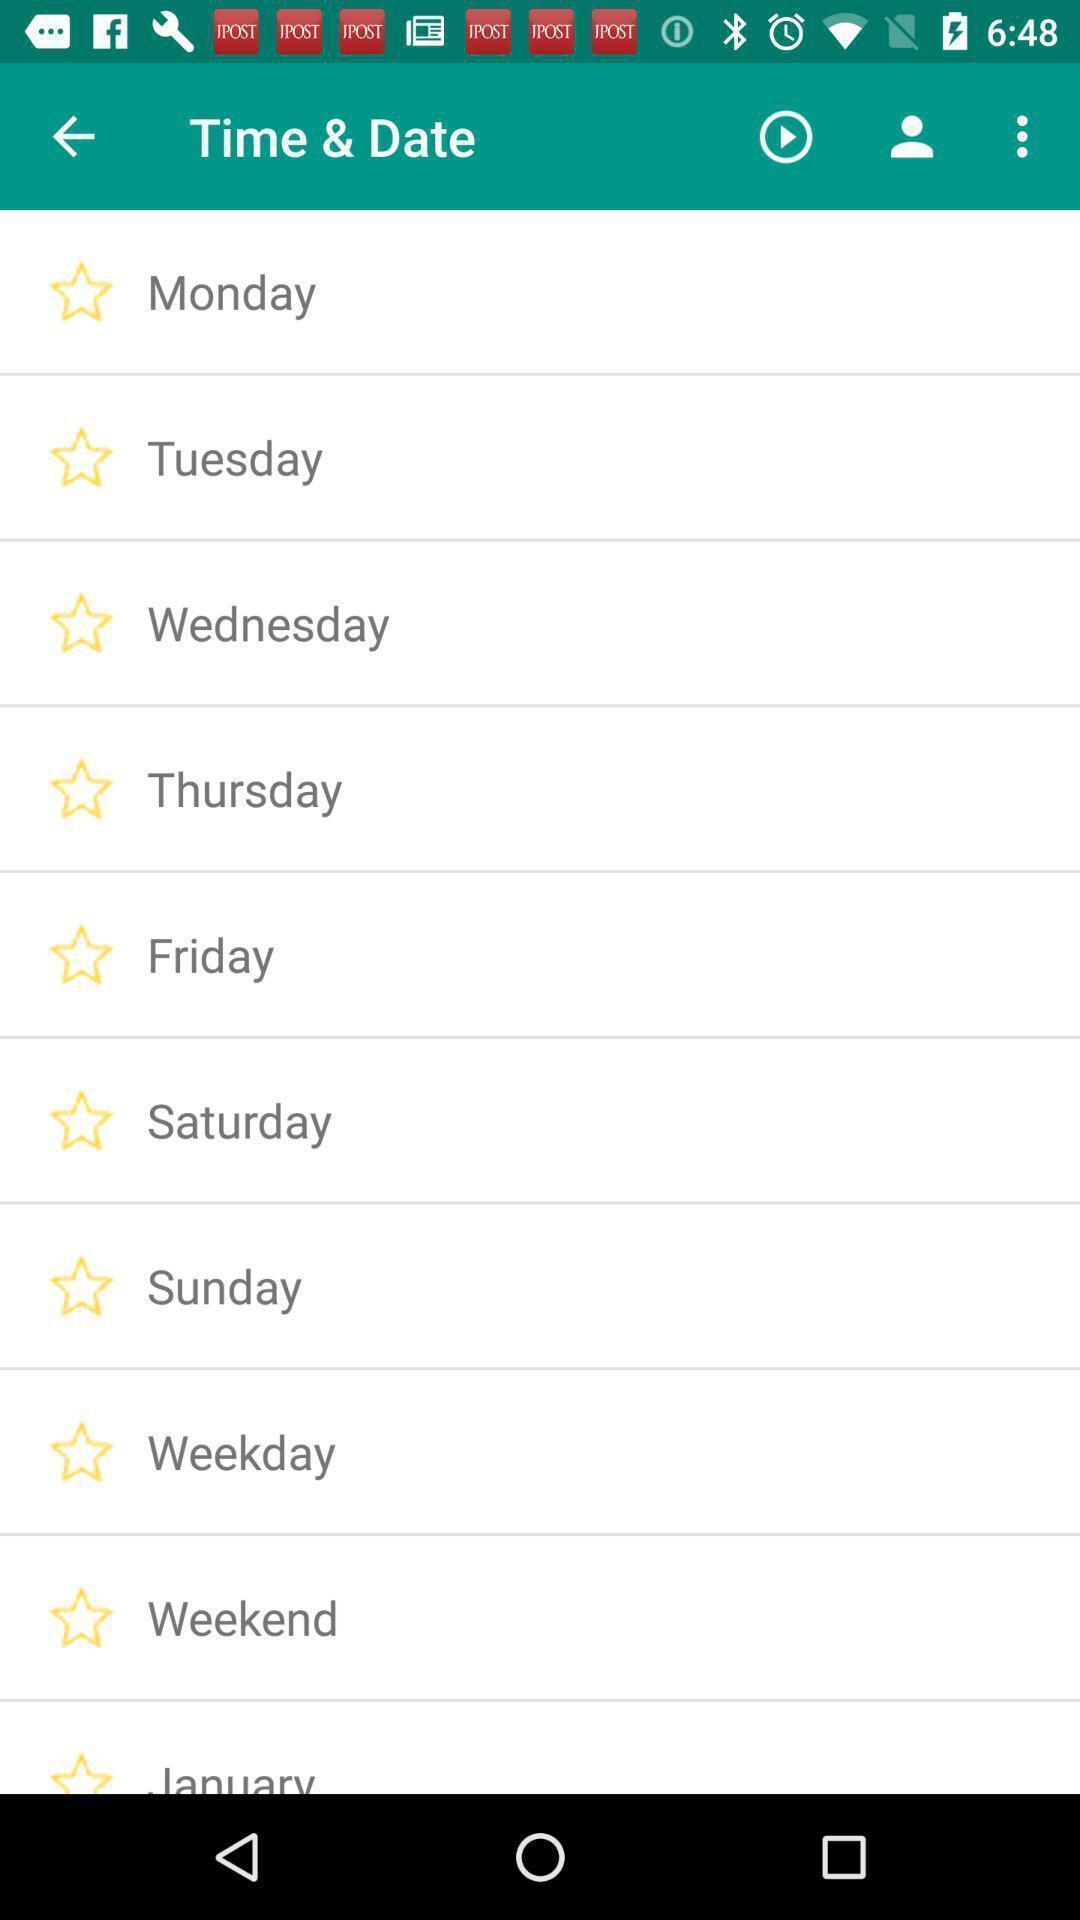Give me a narrative description of this picture. Screen showing list of time and date. 